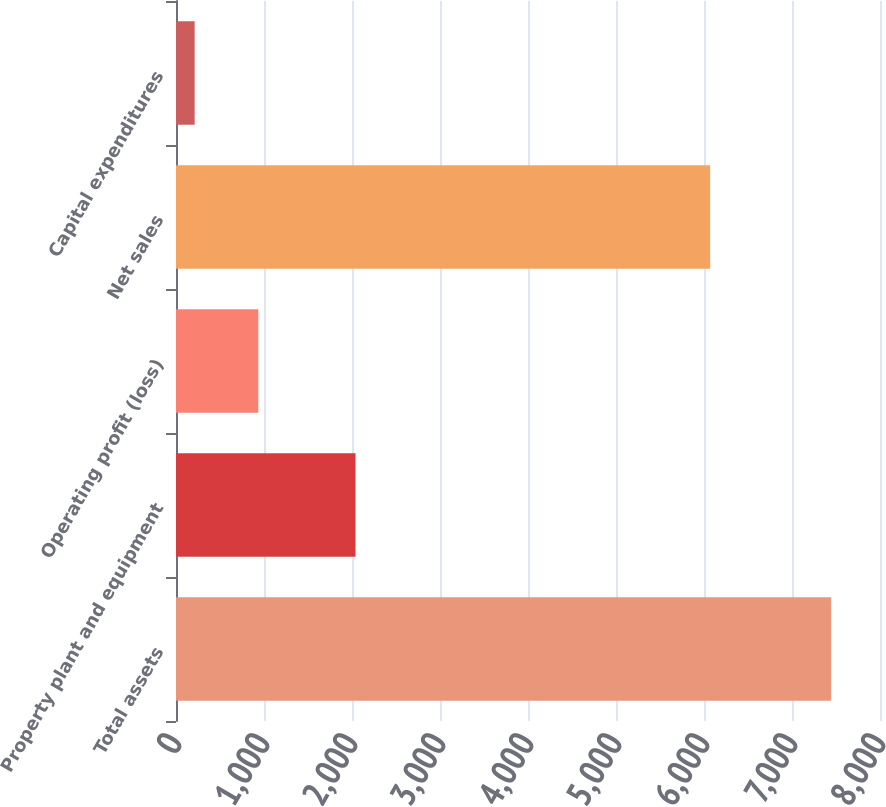<chart> <loc_0><loc_0><loc_500><loc_500><bar_chart><fcel>Total assets<fcel>Property plant and equipment<fcel>Operating profit (loss)<fcel>Net sales<fcel>Capital expenditures<nl><fcel>7445<fcel>2040<fcel>935.3<fcel>6070<fcel>212<nl></chart> 